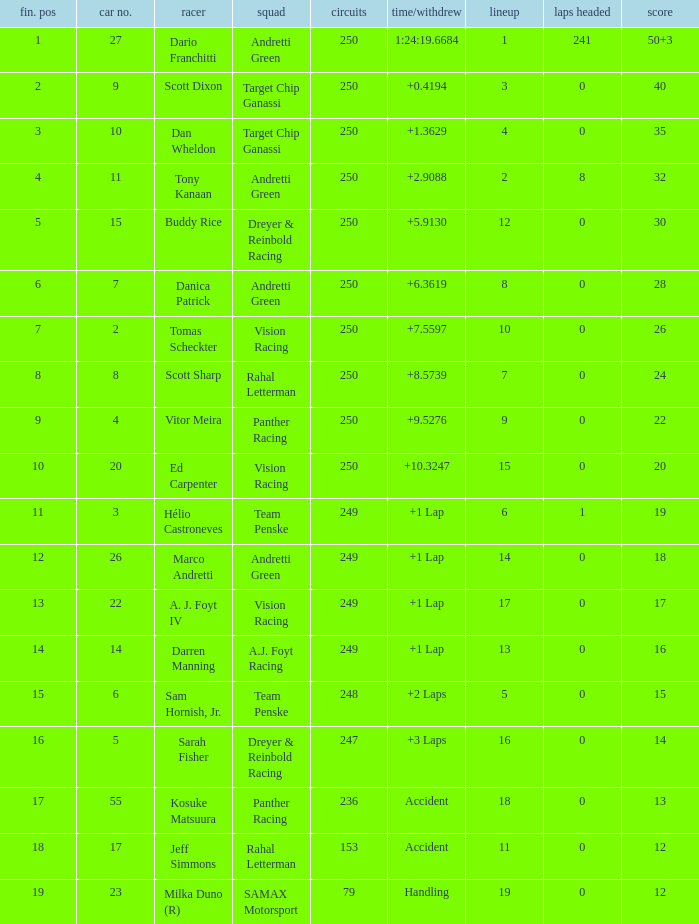Name the least grid for 17 points  17.0. 